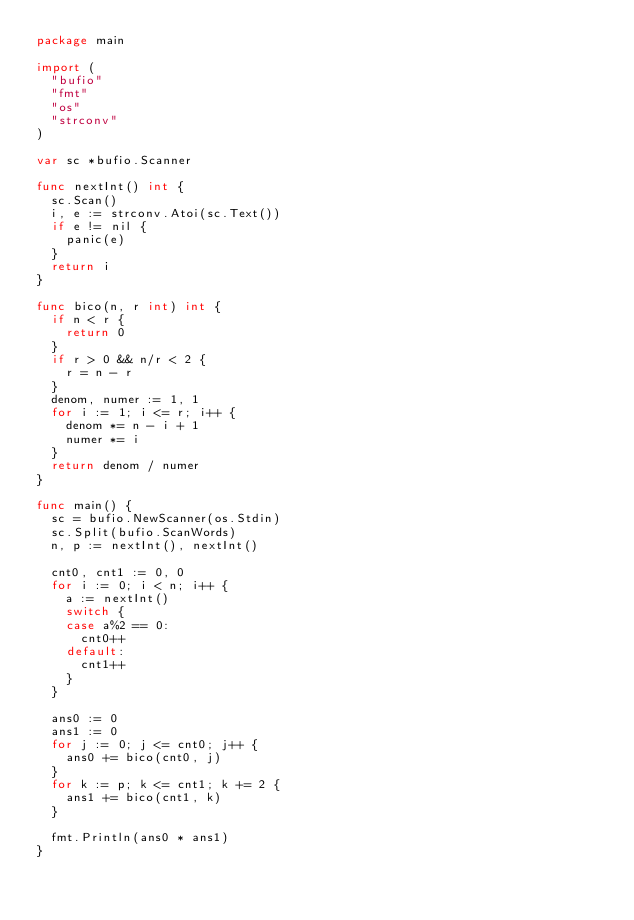<code> <loc_0><loc_0><loc_500><loc_500><_Go_>package main

import (
	"bufio"
	"fmt"
	"os"
	"strconv"
)

var sc *bufio.Scanner

func nextInt() int {
	sc.Scan()
	i, e := strconv.Atoi(sc.Text())
	if e != nil {
		panic(e)
	}
	return i
}

func bico(n, r int) int {
	if n < r {
		return 0
	}
	if r > 0 && n/r < 2 {
		r = n - r
	}
	denom, numer := 1, 1
	for i := 1; i <= r; i++ {
		denom *= n - i + 1
		numer *= i
	}
	return denom / numer
}

func main() {
	sc = bufio.NewScanner(os.Stdin)
	sc.Split(bufio.ScanWords)
	n, p := nextInt(), nextInt()

	cnt0, cnt1 := 0, 0
	for i := 0; i < n; i++ {
		a := nextInt()
		switch {
		case a%2 == 0:
			cnt0++
		default:
			cnt1++
		}
	}

	ans0 := 0
	ans1 := 0
	for j := 0; j <= cnt0; j++ {
		ans0 += bico(cnt0, j)
	}
	for k := p; k <= cnt1; k += 2 {
		ans1 += bico(cnt1, k)
	}

	fmt.Println(ans0 * ans1)
}
</code> 